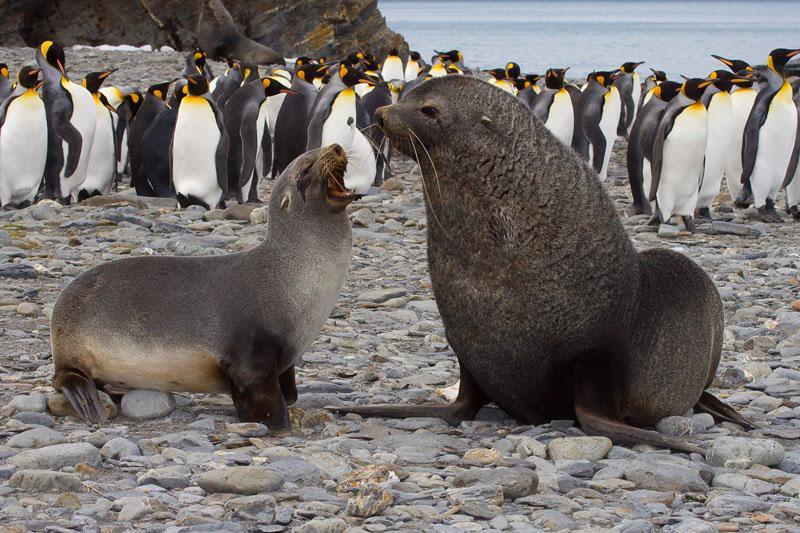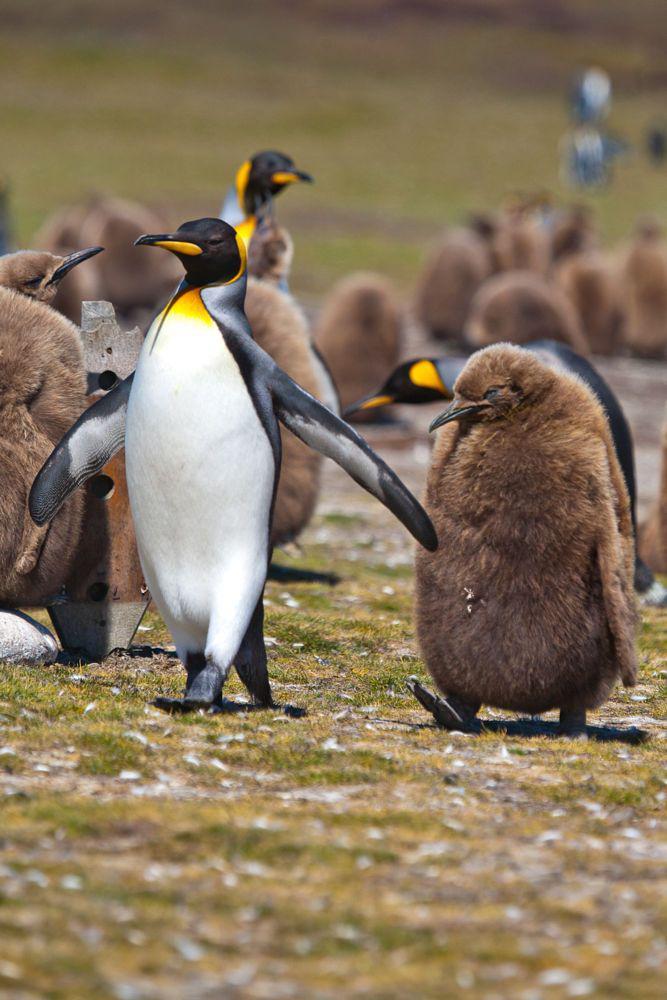The first image is the image on the left, the second image is the image on the right. Considering the images on both sides, is "The ocean is visible." valid? Answer yes or no. Yes. The first image is the image on the left, the second image is the image on the right. Assess this claim about the two images: "There is one seal on the ground in one of the images.". Correct or not? Answer yes or no. No. 